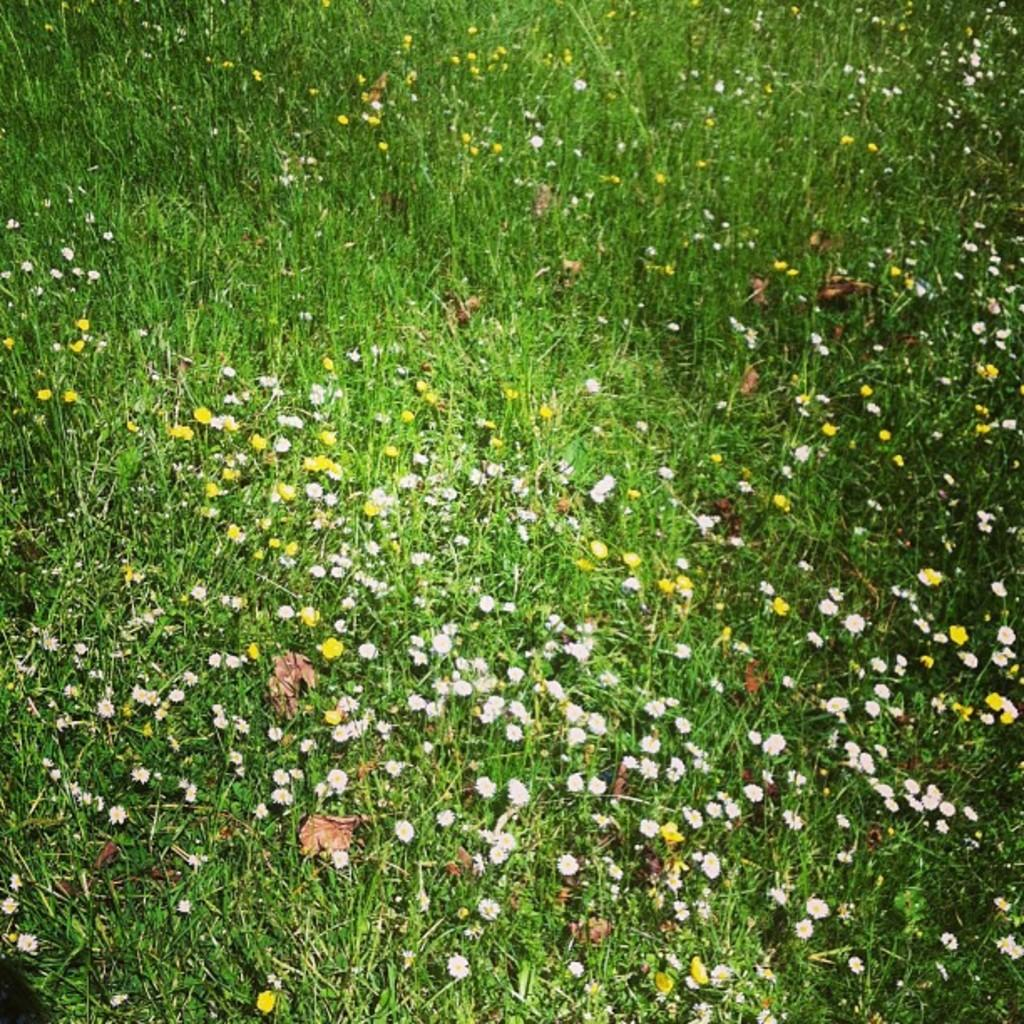What type of vegetation is at the bottom of the image? There is grass at the bottom of the image. What other natural elements can be seen in the image? There are flowers and dry leaves present in the image. What type of guitar is being played by the goose in the image? There is no guitar or goose present in the image. How many hammers can be seen in the image? There are no hammers present in the image. 